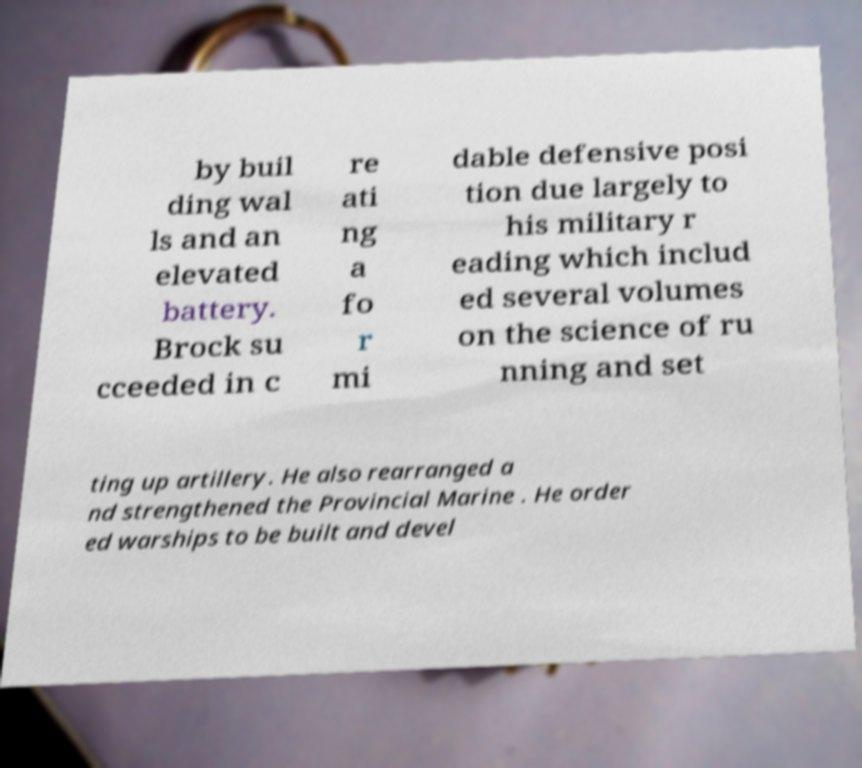There's text embedded in this image that I need extracted. Can you transcribe it verbatim? by buil ding wal ls and an elevated battery. Brock su cceeded in c re ati ng a fo r mi dable defensive posi tion due largely to his military r eading which includ ed several volumes on the science of ru nning and set ting up artillery. He also rearranged a nd strengthened the Provincial Marine . He order ed warships to be built and devel 